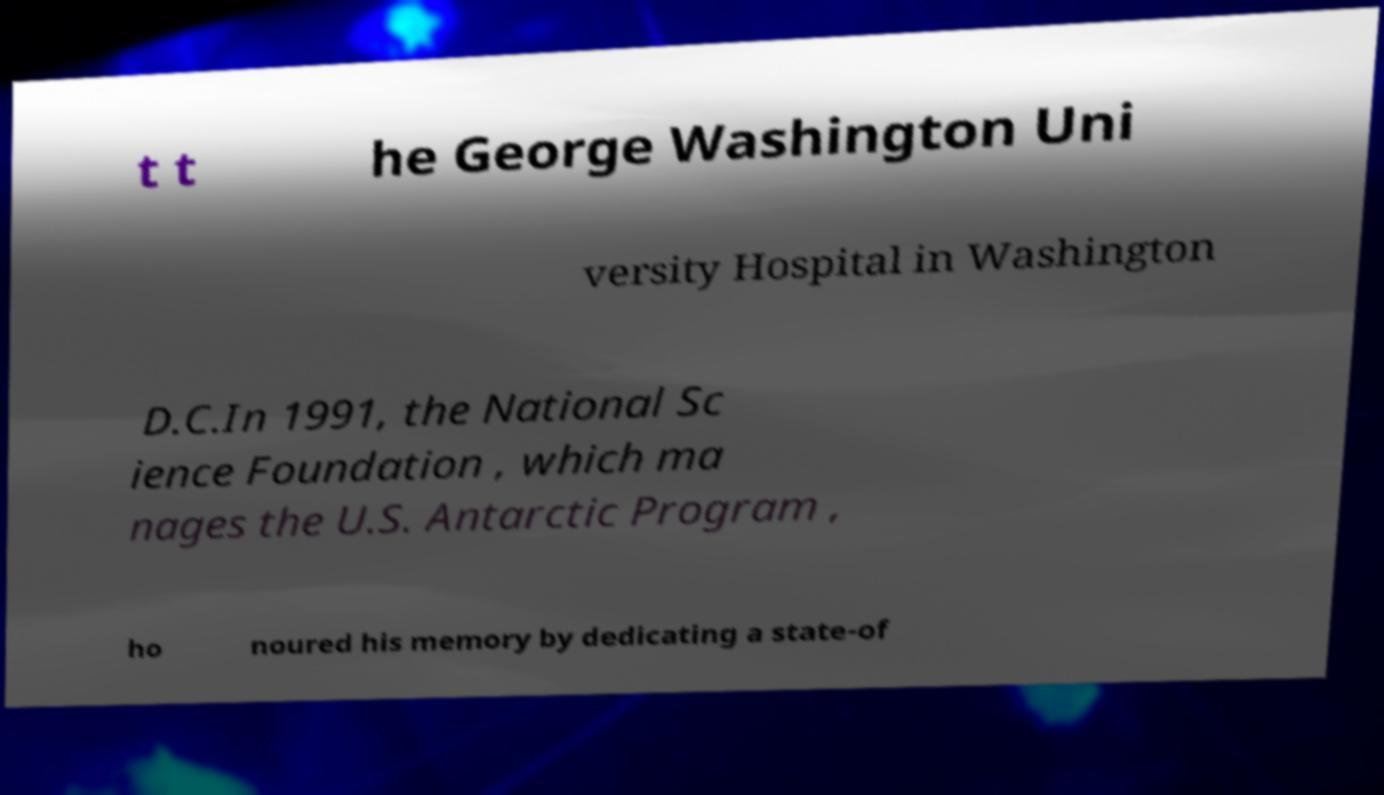I need the written content from this picture converted into text. Can you do that? t t he George Washington Uni versity Hospital in Washington D.C.In 1991, the National Sc ience Foundation , which ma nages the U.S. Antarctic Program , ho noured his memory by dedicating a state-of 